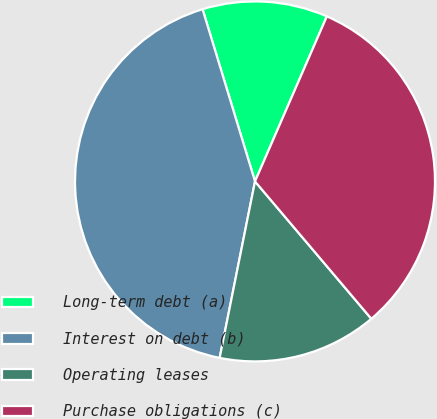Convert chart. <chart><loc_0><loc_0><loc_500><loc_500><pie_chart><fcel>Long-term debt (a)<fcel>Interest on debt (b)<fcel>Operating leases<fcel>Purchase obligations (c)<nl><fcel>11.24%<fcel>42.14%<fcel>14.33%<fcel>32.28%<nl></chart> 